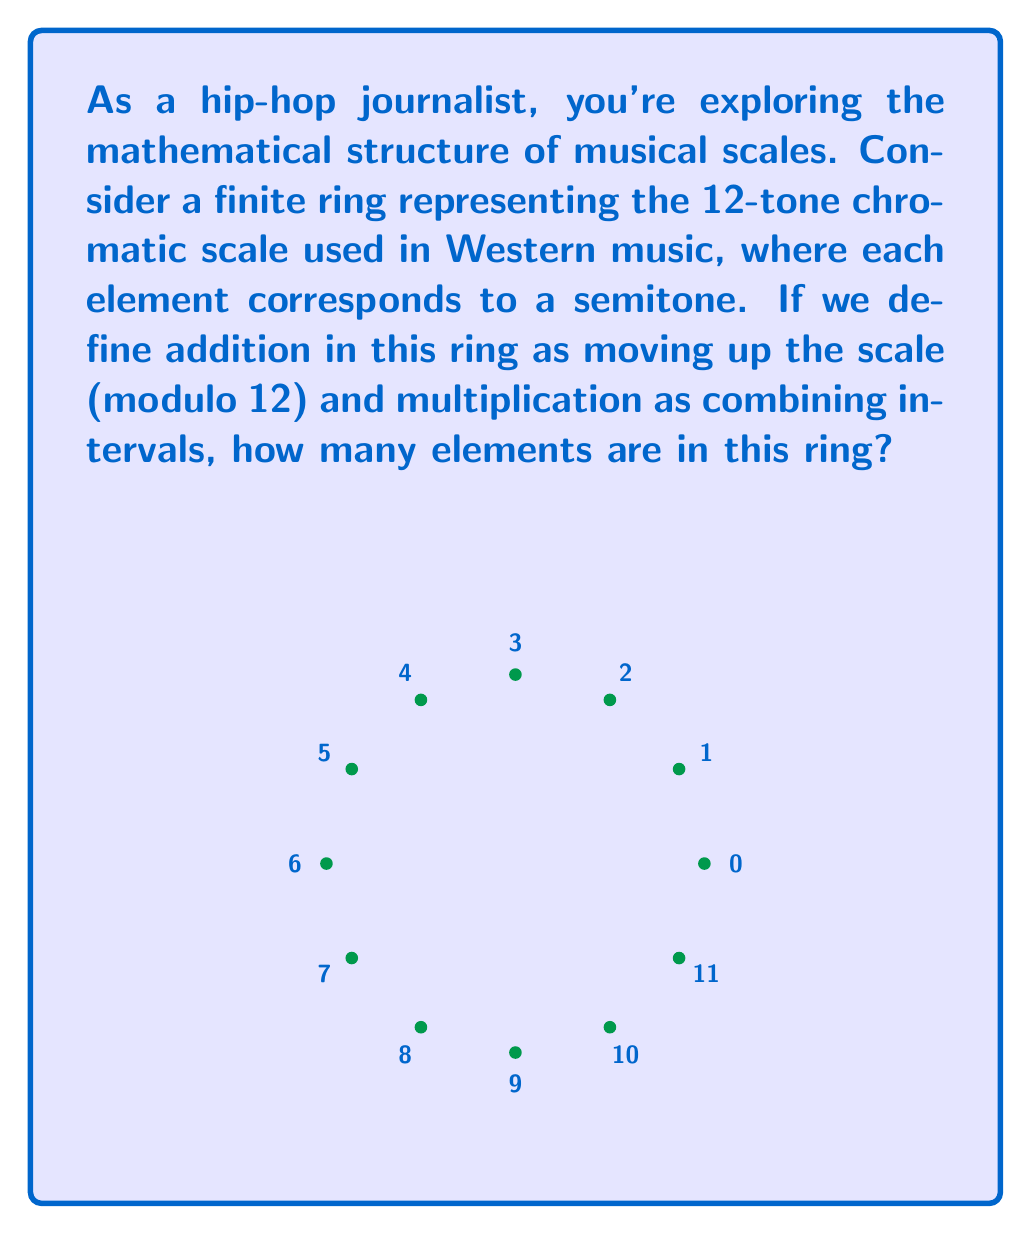Provide a solution to this math problem. To determine the number of elements in this finite ring, we need to consider the structure of the 12-tone chromatic scale:

1. The chromatic scale consists of 12 semitones, which we can number from 0 to 11.

2. In ring theory, we need to ensure that this set is closed under addition and multiplication:

   a) Addition: Moving up the scale is equivalent to addition modulo 12. 
      For example, $7 + 6 \equiv 1 \pmod{12}$ (moving up 6 semitones from G takes us to C#/Db).

   b) Multiplication: Combining intervals is equivalent to multiplication modulo 12.
      For example, $4 \times 3 \equiv 0 \pmod{12}$ (a major third interval repeated 3 times brings us back to the starting note).

3. The identity element for addition is 0 (not moving), and for multiplication is 1 (unison interval).

4. Every element has an additive inverse (e.g., 5 and 7 are inverses as $5 + 7 \equiv 0 \pmod{12}$).

5. The multiplicative inverses exist for elements coprime to 12 (1, 5, 7, 11).

Therefore, the set $\{0, 1, 2, ..., 11\}$ under addition and multiplication modulo 12 forms a valid finite ring, known as $\mathbb{Z}_{12}$.

The number of elements in this ring is simply the number of distinct semitones in the chromatic scale, which is 12.
Answer: 12 